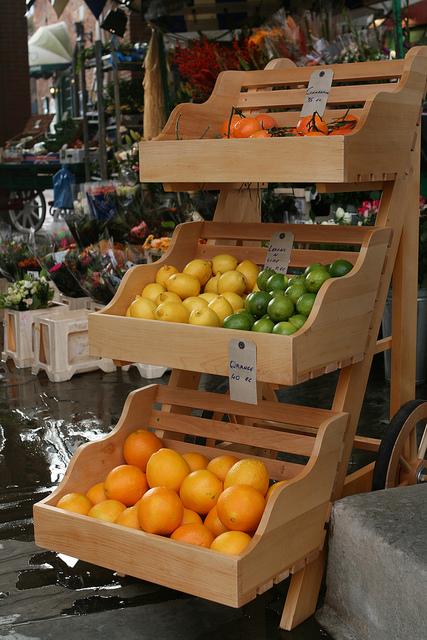How many different levels of shelves are there?
Keep it brief. 3. What is the shelf contains?
Write a very short answer. Fruit. What kinds of fruits and vegetables are here?
Be succinct. Oranges, limes, lemons and tangerines. 